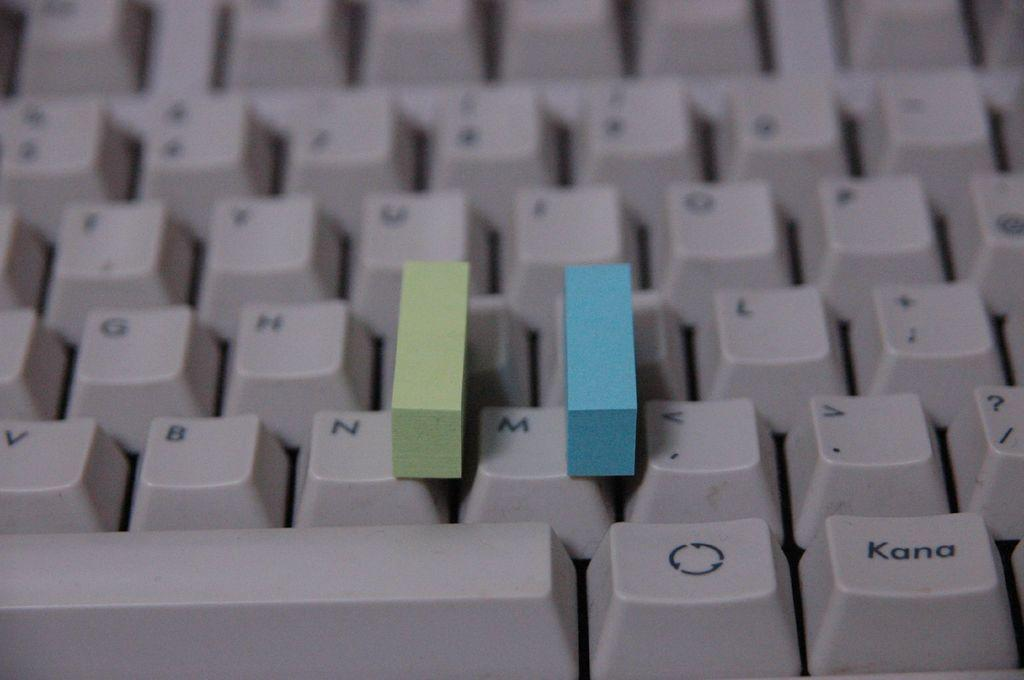<image>
Present a compact description of the photo's key features. A keyboard with a green and blue block surrounding the letter M. 